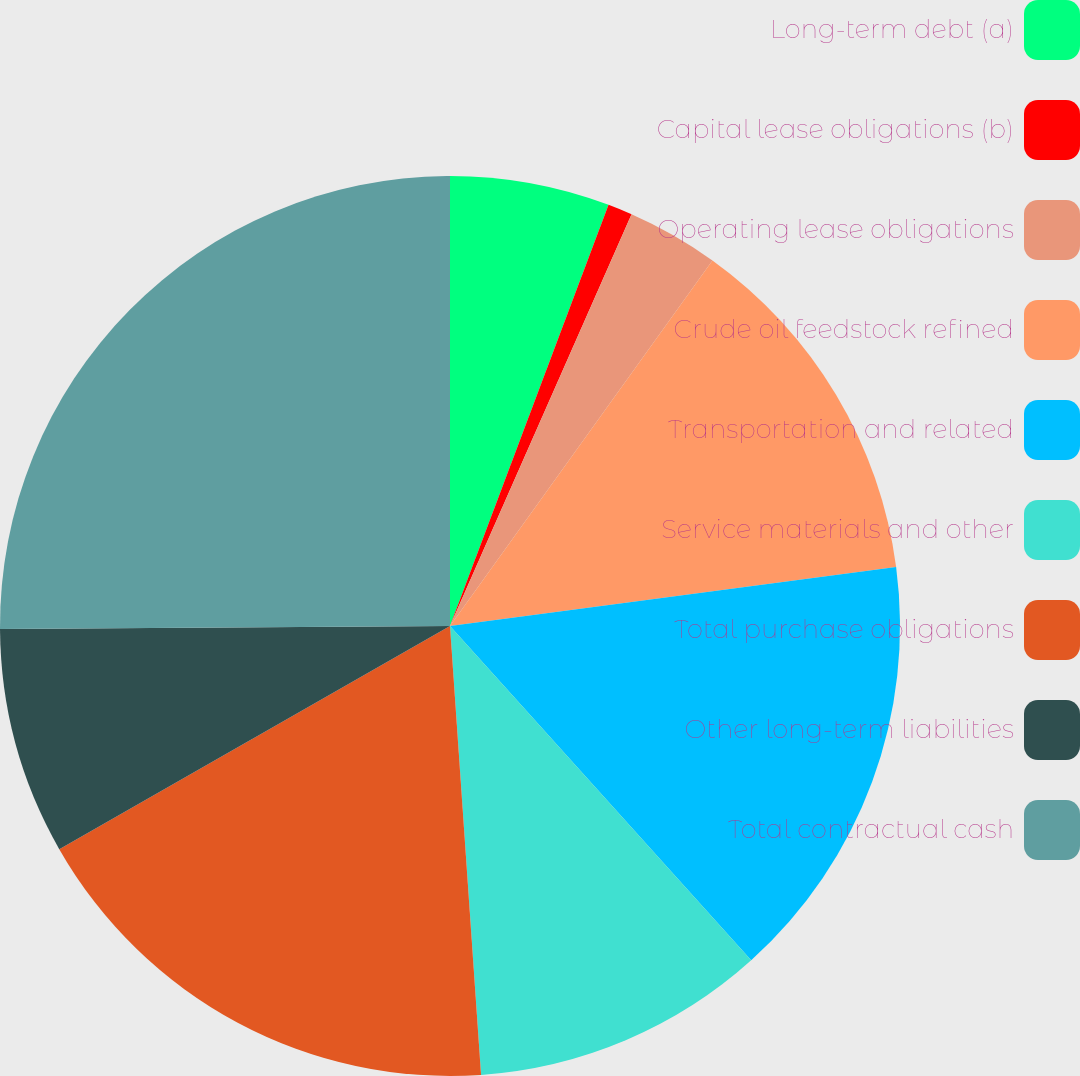Convert chart. <chart><loc_0><loc_0><loc_500><loc_500><pie_chart><fcel>Long-term debt (a)<fcel>Capital lease obligations (b)<fcel>Operating lease obligations<fcel>Crude oil feedstock refined<fcel>Transportation and related<fcel>Service materials and other<fcel>Total purchase obligations<fcel>Other long-term liabilities<fcel>Total contractual cash<nl><fcel>5.73%<fcel>0.88%<fcel>3.3%<fcel>13.0%<fcel>15.42%<fcel>10.57%<fcel>17.84%<fcel>8.15%<fcel>25.11%<nl></chart> 